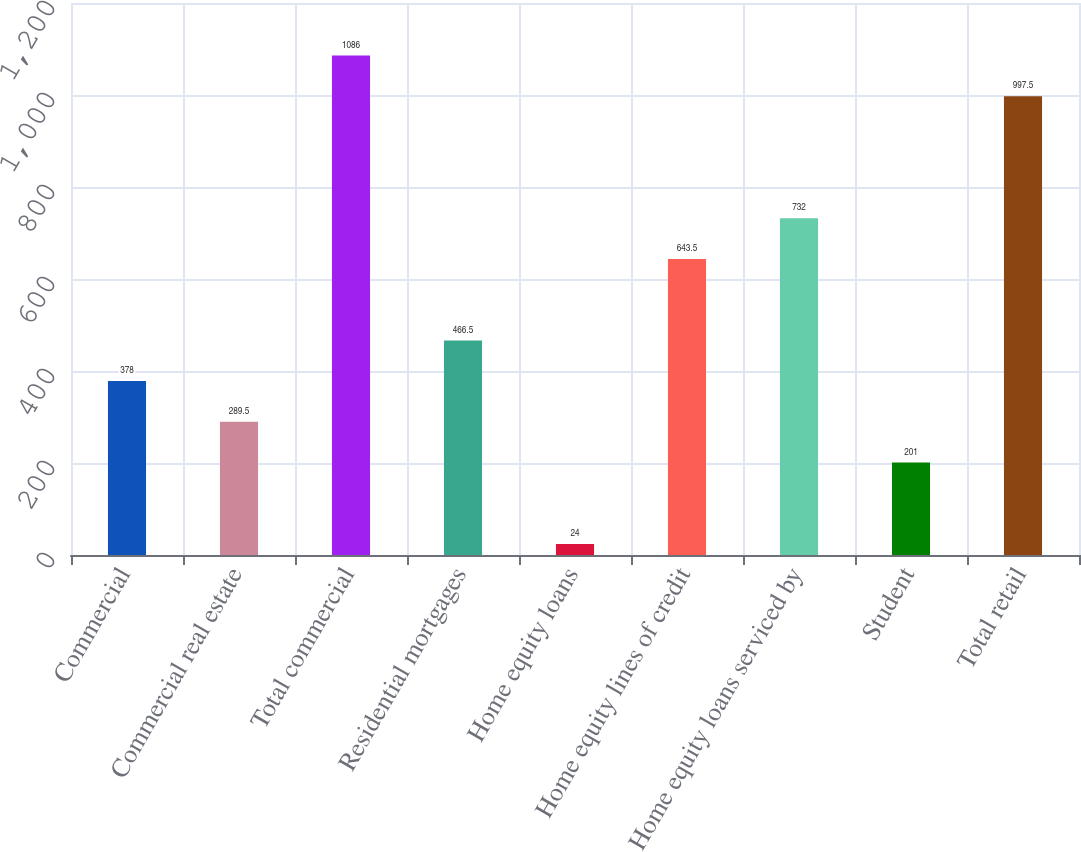<chart> <loc_0><loc_0><loc_500><loc_500><bar_chart><fcel>Commercial<fcel>Commercial real estate<fcel>Total commercial<fcel>Residential mortgages<fcel>Home equity loans<fcel>Home equity lines of credit<fcel>Home equity loans serviced by<fcel>Student<fcel>Total retail<nl><fcel>378<fcel>289.5<fcel>1086<fcel>466.5<fcel>24<fcel>643.5<fcel>732<fcel>201<fcel>997.5<nl></chart> 